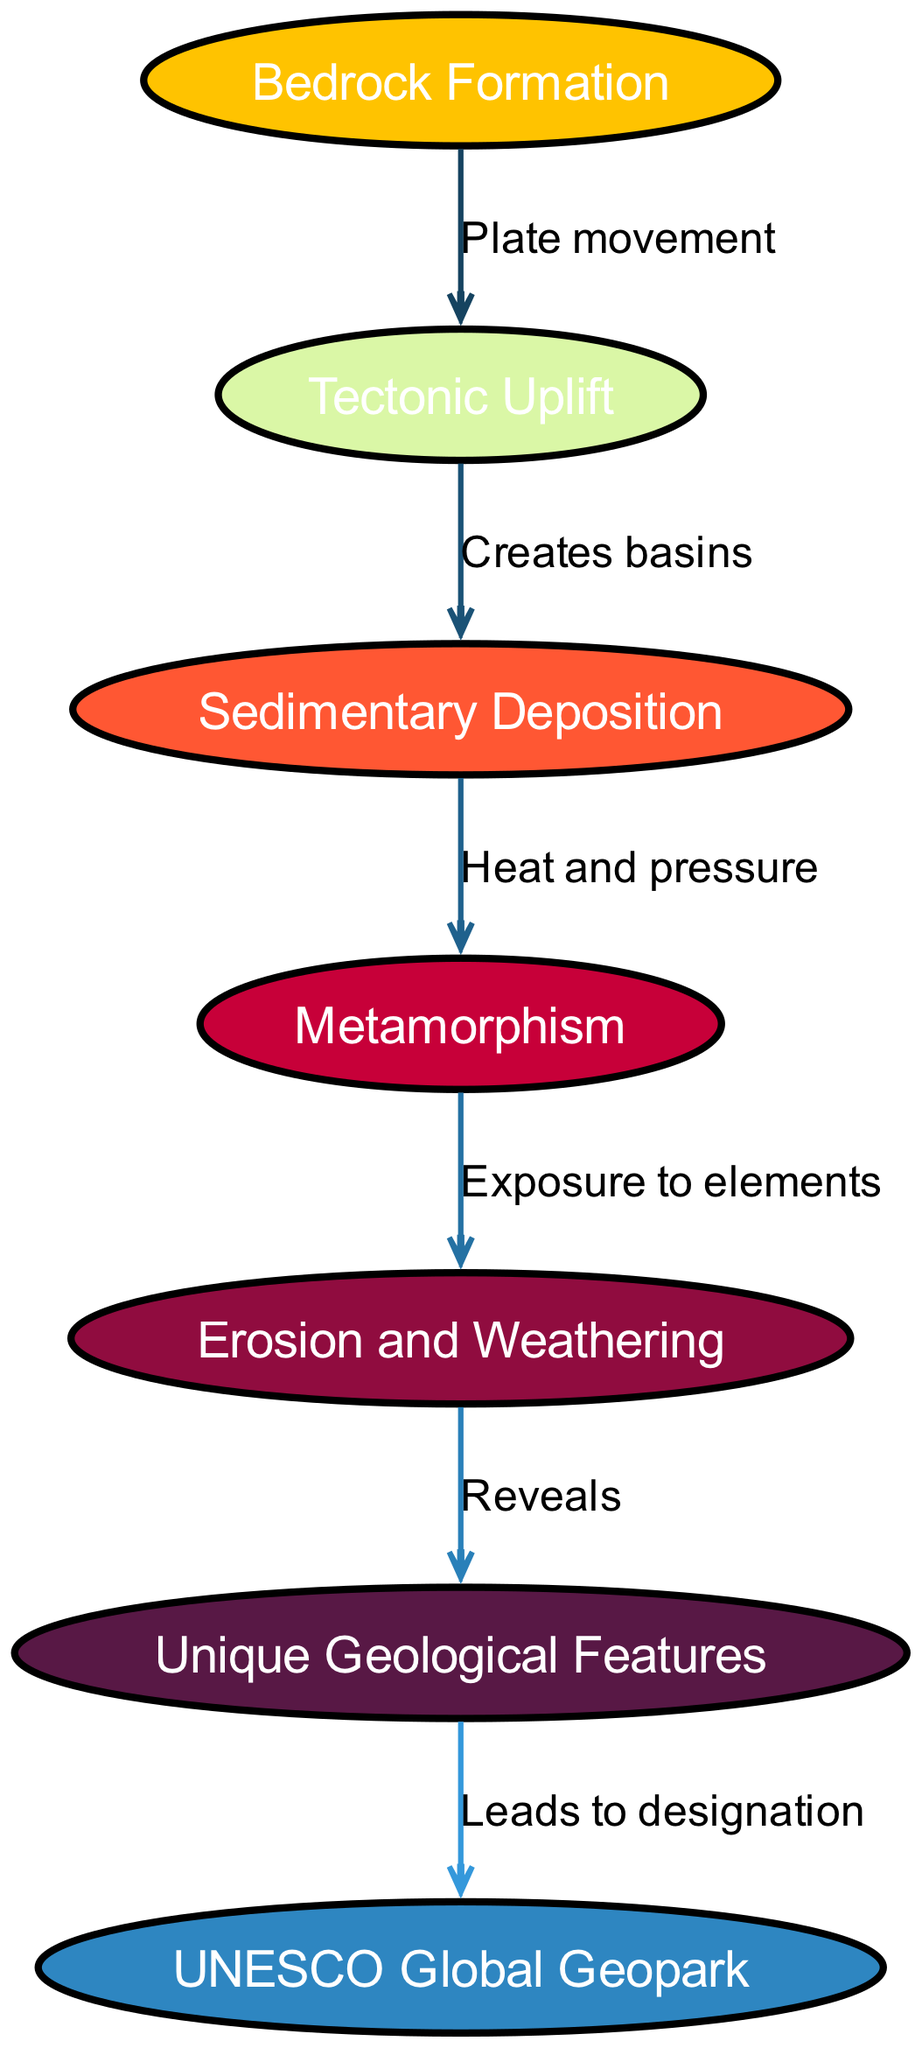What is the initial process in the formation of a UNESCO Global Geopark? The diagram indicates that the initial process is "Bedrock Formation," as it is the first node in the sequence of geological processes leading to the formation of a Global Geopark.
Answer: Bedrock Formation How many nodes are represented in the diagram? By counting each unique component represented in the diagram, we identify seven nodes, including Bedrock Formation, Tectonic Uplift, Sedimentary Deposition, Metamorphism, Erosion and Weathering, Unique Geological Features, and UNESCO Global Geopark.
Answer: 7 What is the relationship between "Tectonic Uplift" and "Sedimentary Deposition"? The edge connecting these nodes is labeled "Creates basins," indicating that tectonic uplift leads to the formation of basins where sedimentary deposition occurs.
Answer: Creates basins What process follows Metamorphism in the geological formation? According to the diagram, the process that follows Metamorphism is "Erosion and Weathering," as represented by the directed edge connecting these two nodes.
Answer: Erosion and Weathering Which geological feature is revealed through Erosion and Weathering? The diagram states that the process of Erosion and Weathering reveals "Unique Geological Features," showing that this process is responsible for uncovering these features.
Answer: Unique Geological Features How does the unique geological features contribute to the UNESCO designation? The edge connecting "Unique Geological Features" to "UNESCO Global Geopark" is labeled "Leads to designation," indicating that the unique features are essential for achieving UNESCO status.
Answer: Leads to designation What combination of processes leads to sedimentary deposition? To determine this, we follow the flow from "Tectonic Uplift" to "Sedimentary Deposition." The process creating conditions for sedimentary deposition involves "Tectonic Uplift," which creates basins for the sediment to settle.
Answer: Tectonic Uplift What is the role of heat and pressure in the geological process? The edge labeled "Heat and pressure" connects "Sedimentary Deposition" to "Metamorphism," indicating that these forces are crucial for transforming sedimentary rock into metamorphic rock during the geological process.
Answer: Heat and pressure 